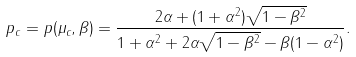Convert formula to latex. <formula><loc_0><loc_0><loc_500><loc_500>p _ { c } = p ( \mu _ { c } , \beta ) = \frac { 2 \alpha + ( 1 + \alpha ^ { 2 } ) \sqrt { 1 - \beta ^ { 2 } } } { 1 + \alpha ^ { 2 } + 2 \alpha \sqrt { 1 - \beta ^ { 2 } } - \beta ( 1 - \alpha ^ { 2 } ) } .</formula> 